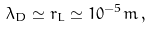<formula> <loc_0><loc_0><loc_500><loc_500>\lambda _ { D } \simeq r _ { L } \simeq 1 0 ^ { - 5 } m \, ,</formula> 